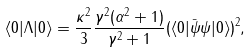<formula> <loc_0><loc_0><loc_500><loc_500>\langle 0 | \Lambda | 0 \rangle = \frac { \kappa ^ { 2 } } { 3 } \frac { \gamma ^ { 2 } ( \alpha ^ { 2 } + 1 ) } { \gamma ^ { 2 } + 1 } ( \langle 0 | \bar { \psi } \psi | 0 \rangle ) ^ { 2 } ,</formula> 